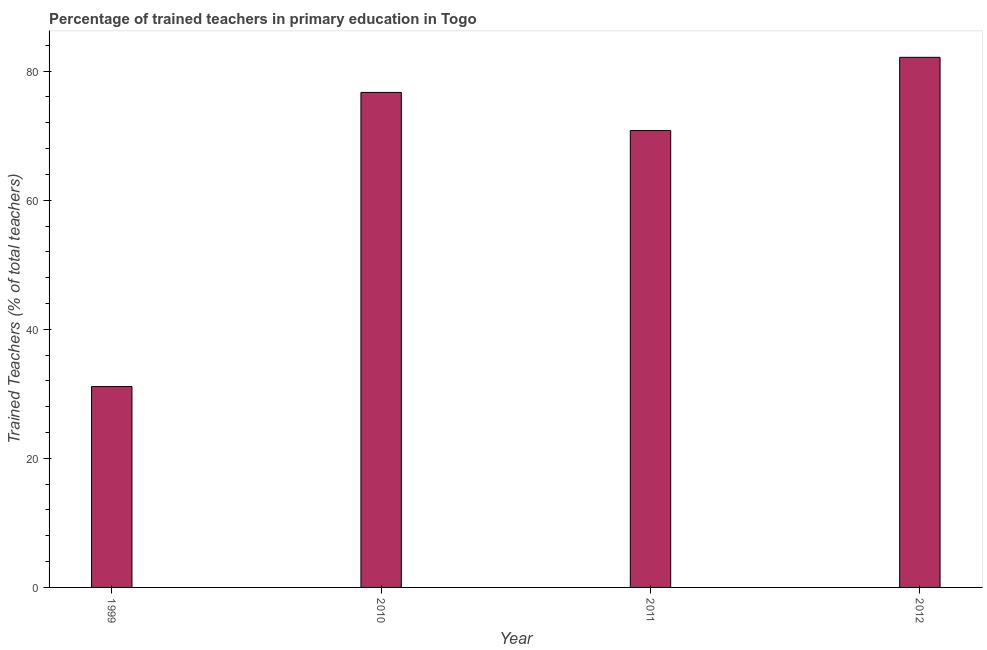Does the graph contain any zero values?
Your answer should be compact. No. What is the title of the graph?
Offer a terse response. Percentage of trained teachers in primary education in Togo. What is the label or title of the Y-axis?
Provide a succinct answer. Trained Teachers (% of total teachers). What is the percentage of trained teachers in 2010?
Keep it short and to the point. 76.7. Across all years, what is the maximum percentage of trained teachers?
Keep it short and to the point. 82.14. Across all years, what is the minimum percentage of trained teachers?
Your answer should be compact. 31.12. In which year was the percentage of trained teachers maximum?
Give a very brief answer. 2012. What is the sum of the percentage of trained teachers?
Your answer should be very brief. 260.76. What is the difference between the percentage of trained teachers in 1999 and 2011?
Provide a short and direct response. -39.67. What is the average percentage of trained teachers per year?
Give a very brief answer. 65.19. What is the median percentage of trained teachers?
Your answer should be very brief. 73.75. Do a majority of the years between 1999 and 2012 (inclusive) have percentage of trained teachers greater than 28 %?
Keep it short and to the point. Yes. What is the ratio of the percentage of trained teachers in 1999 to that in 2011?
Your answer should be compact. 0.44. What is the difference between the highest and the second highest percentage of trained teachers?
Give a very brief answer. 5.44. What is the difference between the highest and the lowest percentage of trained teachers?
Your response must be concise. 51.01. In how many years, is the percentage of trained teachers greater than the average percentage of trained teachers taken over all years?
Give a very brief answer. 3. How many bars are there?
Keep it short and to the point. 4. Are all the bars in the graph horizontal?
Keep it short and to the point. No. How many years are there in the graph?
Your response must be concise. 4. What is the difference between two consecutive major ticks on the Y-axis?
Make the answer very short. 20. What is the Trained Teachers (% of total teachers) of 1999?
Provide a short and direct response. 31.12. What is the Trained Teachers (% of total teachers) of 2010?
Your answer should be compact. 76.7. What is the Trained Teachers (% of total teachers) in 2011?
Provide a short and direct response. 70.8. What is the Trained Teachers (% of total teachers) of 2012?
Keep it short and to the point. 82.14. What is the difference between the Trained Teachers (% of total teachers) in 1999 and 2010?
Your answer should be compact. -45.58. What is the difference between the Trained Teachers (% of total teachers) in 1999 and 2011?
Make the answer very short. -39.67. What is the difference between the Trained Teachers (% of total teachers) in 1999 and 2012?
Your answer should be compact. -51.01. What is the difference between the Trained Teachers (% of total teachers) in 2010 and 2011?
Provide a succinct answer. 5.91. What is the difference between the Trained Teachers (% of total teachers) in 2010 and 2012?
Your answer should be very brief. -5.44. What is the difference between the Trained Teachers (% of total teachers) in 2011 and 2012?
Keep it short and to the point. -11.34. What is the ratio of the Trained Teachers (% of total teachers) in 1999 to that in 2010?
Offer a terse response. 0.41. What is the ratio of the Trained Teachers (% of total teachers) in 1999 to that in 2011?
Your response must be concise. 0.44. What is the ratio of the Trained Teachers (% of total teachers) in 1999 to that in 2012?
Keep it short and to the point. 0.38. What is the ratio of the Trained Teachers (% of total teachers) in 2010 to that in 2011?
Provide a short and direct response. 1.08. What is the ratio of the Trained Teachers (% of total teachers) in 2010 to that in 2012?
Offer a very short reply. 0.93. What is the ratio of the Trained Teachers (% of total teachers) in 2011 to that in 2012?
Your answer should be compact. 0.86. 